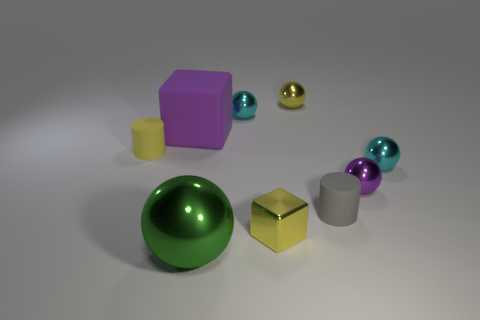Are there any cyan spheres made of the same material as the yellow cube?
Your response must be concise. Yes. There is a cyan ball that is behind the tiny cylinder that is left of the purple cube; what is its material?
Provide a succinct answer. Metal. There is a gray matte cylinder that is on the left side of the ball on the right side of the purple shiny sphere that is to the right of the green metal thing; how big is it?
Your answer should be compact. Small. What number of other objects are there of the same shape as the big green thing?
Provide a short and direct response. 4. Do the matte cylinder in front of the yellow cylinder and the large object that is behind the large metal thing have the same color?
Make the answer very short. No. The rubber cylinder that is the same size as the gray matte thing is what color?
Provide a short and direct response. Yellow. Is there a small metallic thing of the same color as the large rubber object?
Keep it short and to the point. Yes. Is the size of the cylinder to the left of the gray object the same as the big purple object?
Your answer should be very brief. No. Are there the same number of green spheres right of the small purple metallic thing and purple spheres?
Offer a terse response. No. How many things are yellow metallic objects in front of the yellow matte thing or tiny cyan metallic spheres?
Provide a short and direct response. 3. 